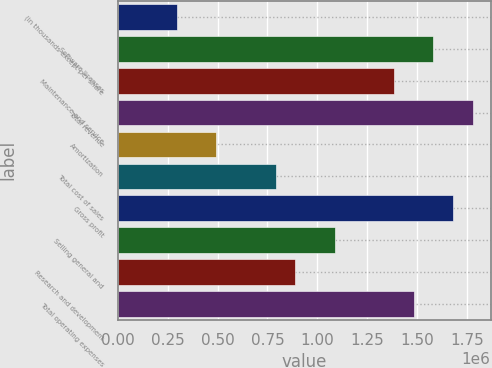Convert chart. <chart><loc_0><loc_0><loc_500><loc_500><bar_chart><fcel>(in thousands except per share<fcel>Software licenses<fcel>Maintenance and service<fcel>Total revenue<fcel>Amortization<fcel>Total cost of sales<fcel>Gross profit<fcel>Selling general and<fcel>Research and development<fcel>Total operating expenses<nl><fcel>296542<fcel>1.58154e+06<fcel>1.38385e+06<fcel>1.77923e+06<fcel>494234<fcel>790773<fcel>1.68039e+06<fcel>1.08731e+06<fcel>889619<fcel>1.4827e+06<nl></chart> 